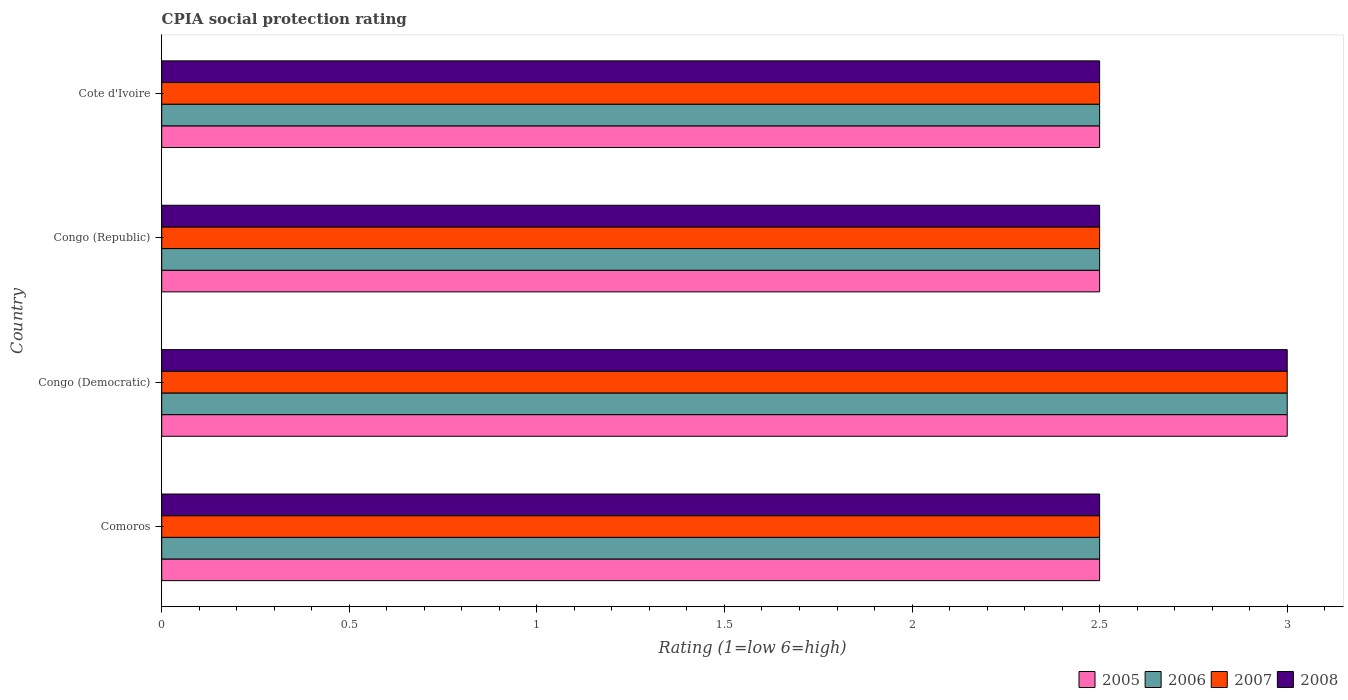Are the number of bars on each tick of the Y-axis equal?
Your answer should be compact. Yes. How many bars are there on the 3rd tick from the top?
Offer a terse response. 4. What is the label of the 2nd group of bars from the top?
Your response must be concise. Congo (Republic). In how many cases, is the number of bars for a given country not equal to the number of legend labels?
Make the answer very short. 0. What is the CPIA rating in 2006 in Cote d'Ivoire?
Your answer should be compact. 2.5. Across all countries, what is the maximum CPIA rating in 2005?
Give a very brief answer. 3. Across all countries, what is the minimum CPIA rating in 2005?
Make the answer very short. 2.5. In which country was the CPIA rating in 2008 maximum?
Ensure brevity in your answer.  Congo (Democratic). In which country was the CPIA rating in 2006 minimum?
Offer a terse response. Comoros. What is the total CPIA rating in 2005 in the graph?
Your response must be concise. 10.5. What is the difference between the CPIA rating in 2007 in Comoros and that in Cote d'Ivoire?
Provide a succinct answer. 0. What is the average CPIA rating in 2005 per country?
Offer a very short reply. 2.62. What is the difference between the CPIA rating in 2007 and CPIA rating in 2005 in Cote d'Ivoire?
Offer a very short reply. 0. In how many countries, is the CPIA rating in 2005 greater than 0.7 ?
Keep it short and to the point. 4. Is the difference between the CPIA rating in 2007 in Congo (Democratic) and Cote d'Ivoire greater than the difference between the CPIA rating in 2005 in Congo (Democratic) and Cote d'Ivoire?
Ensure brevity in your answer.  No. Is it the case that in every country, the sum of the CPIA rating in 2005 and CPIA rating in 2007 is greater than the sum of CPIA rating in 2006 and CPIA rating in 2008?
Your answer should be very brief. No. What does the 2nd bar from the top in Comoros represents?
Make the answer very short. 2007. What does the 3rd bar from the bottom in Congo (Democratic) represents?
Offer a very short reply. 2007. Is it the case that in every country, the sum of the CPIA rating in 2005 and CPIA rating in 2007 is greater than the CPIA rating in 2008?
Your answer should be very brief. Yes. How many bars are there?
Offer a terse response. 16. Are all the bars in the graph horizontal?
Offer a very short reply. Yes. What is the difference between two consecutive major ticks on the X-axis?
Your answer should be compact. 0.5. Are the values on the major ticks of X-axis written in scientific E-notation?
Ensure brevity in your answer.  No. Where does the legend appear in the graph?
Ensure brevity in your answer.  Bottom right. What is the title of the graph?
Your response must be concise. CPIA social protection rating. Does "1978" appear as one of the legend labels in the graph?
Offer a terse response. No. What is the label or title of the Y-axis?
Make the answer very short. Country. What is the Rating (1=low 6=high) in 2005 in Comoros?
Provide a succinct answer. 2.5. What is the Rating (1=low 6=high) of 2006 in Comoros?
Offer a very short reply. 2.5. What is the Rating (1=low 6=high) of 2007 in Comoros?
Offer a very short reply. 2.5. What is the Rating (1=low 6=high) in 2008 in Comoros?
Your answer should be compact. 2.5. What is the Rating (1=low 6=high) of 2005 in Congo (Democratic)?
Provide a short and direct response. 3. What is the Rating (1=low 6=high) in 2006 in Congo (Democratic)?
Your response must be concise. 3. What is the Rating (1=low 6=high) of 2007 in Congo (Democratic)?
Your answer should be very brief. 3. What is the Rating (1=low 6=high) of 2008 in Congo (Democratic)?
Give a very brief answer. 3. What is the Rating (1=low 6=high) in 2005 in Congo (Republic)?
Offer a terse response. 2.5. What is the Rating (1=low 6=high) in 2006 in Congo (Republic)?
Your answer should be compact. 2.5. What is the Rating (1=low 6=high) of 2008 in Congo (Republic)?
Your response must be concise. 2.5. What is the Rating (1=low 6=high) of 2005 in Cote d'Ivoire?
Provide a succinct answer. 2.5. What is the Rating (1=low 6=high) of 2006 in Cote d'Ivoire?
Make the answer very short. 2.5. What is the Rating (1=low 6=high) of 2007 in Cote d'Ivoire?
Your answer should be compact. 2.5. Across all countries, what is the maximum Rating (1=low 6=high) of 2005?
Your answer should be very brief. 3. Across all countries, what is the maximum Rating (1=low 6=high) of 2006?
Offer a terse response. 3. Across all countries, what is the maximum Rating (1=low 6=high) of 2008?
Your answer should be compact. 3. Across all countries, what is the minimum Rating (1=low 6=high) of 2006?
Make the answer very short. 2.5. Across all countries, what is the minimum Rating (1=low 6=high) of 2007?
Make the answer very short. 2.5. Across all countries, what is the minimum Rating (1=low 6=high) in 2008?
Your answer should be very brief. 2.5. What is the total Rating (1=low 6=high) of 2008 in the graph?
Offer a very short reply. 10.5. What is the difference between the Rating (1=low 6=high) of 2005 in Comoros and that in Congo (Democratic)?
Ensure brevity in your answer.  -0.5. What is the difference between the Rating (1=low 6=high) in 2007 in Comoros and that in Congo (Democratic)?
Your answer should be compact. -0.5. What is the difference between the Rating (1=low 6=high) of 2006 in Comoros and that in Congo (Republic)?
Give a very brief answer. 0. What is the difference between the Rating (1=low 6=high) in 2008 in Comoros and that in Congo (Republic)?
Offer a very short reply. 0. What is the difference between the Rating (1=low 6=high) of 2006 in Comoros and that in Cote d'Ivoire?
Make the answer very short. 0. What is the difference between the Rating (1=low 6=high) of 2008 in Comoros and that in Cote d'Ivoire?
Your response must be concise. 0. What is the difference between the Rating (1=low 6=high) of 2005 in Congo (Democratic) and that in Congo (Republic)?
Ensure brevity in your answer.  0.5. What is the difference between the Rating (1=low 6=high) of 2007 in Congo (Democratic) and that in Congo (Republic)?
Offer a terse response. 0.5. What is the difference between the Rating (1=low 6=high) in 2007 in Congo (Democratic) and that in Cote d'Ivoire?
Provide a succinct answer. 0.5. What is the difference between the Rating (1=low 6=high) in 2008 in Congo (Democratic) and that in Cote d'Ivoire?
Make the answer very short. 0.5. What is the difference between the Rating (1=low 6=high) of 2005 in Congo (Republic) and that in Cote d'Ivoire?
Offer a very short reply. 0. What is the difference between the Rating (1=low 6=high) in 2006 in Congo (Republic) and that in Cote d'Ivoire?
Your answer should be compact. 0. What is the difference between the Rating (1=low 6=high) of 2007 in Congo (Republic) and that in Cote d'Ivoire?
Offer a very short reply. 0. What is the difference between the Rating (1=low 6=high) of 2008 in Congo (Republic) and that in Cote d'Ivoire?
Your response must be concise. 0. What is the difference between the Rating (1=low 6=high) in 2005 in Comoros and the Rating (1=low 6=high) in 2006 in Congo (Democratic)?
Your answer should be compact. -0.5. What is the difference between the Rating (1=low 6=high) of 2005 in Comoros and the Rating (1=low 6=high) of 2007 in Congo (Republic)?
Keep it short and to the point. 0. What is the difference between the Rating (1=low 6=high) in 2005 in Comoros and the Rating (1=low 6=high) in 2008 in Congo (Republic)?
Make the answer very short. 0. What is the difference between the Rating (1=low 6=high) in 2006 in Comoros and the Rating (1=low 6=high) in 2007 in Congo (Republic)?
Give a very brief answer. 0. What is the difference between the Rating (1=low 6=high) in 2005 in Comoros and the Rating (1=low 6=high) in 2008 in Cote d'Ivoire?
Make the answer very short. 0. What is the difference between the Rating (1=low 6=high) in 2006 in Comoros and the Rating (1=low 6=high) in 2007 in Cote d'Ivoire?
Offer a terse response. 0. What is the difference between the Rating (1=low 6=high) of 2007 in Comoros and the Rating (1=low 6=high) of 2008 in Cote d'Ivoire?
Give a very brief answer. 0. What is the difference between the Rating (1=low 6=high) of 2006 in Congo (Democratic) and the Rating (1=low 6=high) of 2008 in Congo (Republic)?
Your answer should be compact. 0.5. What is the difference between the Rating (1=low 6=high) of 2005 in Congo (Democratic) and the Rating (1=low 6=high) of 2006 in Cote d'Ivoire?
Your answer should be very brief. 0.5. What is the difference between the Rating (1=low 6=high) of 2005 in Congo (Democratic) and the Rating (1=low 6=high) of 2008 in Cote d'Ivoire?
Offer a very short reply. 0.5. What is the difference between the Rating (1=low 6=high) in 2006 in Congo (Democratic) and the Rating (1=low 6=high) in 2008 in Cote d'Ivoire?
Your response must be concise. 0.5. What is the difference between the Rating (1=low 6=high) of 2007 in Congo (Democratic) and the Rating (1=low 6=high) of 2008 in Cote d'Ivoire?
Your answer should be very brief. 0.5. What is the difference between the Rating (1=low 6=high) in 2005 in Congo (Republic) and the Rating (1=low 6=high) in 2007 in Cote d'Ivoire?
Your answer should be compact. 0. What is the difference between the Rating (1=low 6=high) in 2005 in Congo (Republic) and the Rating (1=low 6=high) in 2008 in Cote d'Ivoire?
Provide a short and direct response. 0. What is the difference between the Rating (1=low 6=high) in 2007 in Congo (Republic) and the Rating (1=low 6=high) in 2008 in Cote d'Ivoire?
Your answer should be very brief. 0. What is the average Rating (1=low 6=high) of 2005 per country?
Keep it short and to the point. 2.62. What is the average Rating (1=low 6=high) of 2006 per country?
Make the answer very short. 2.62. What is the average Rating (1=low 6=high) in 2007 per country?
Offer a terse response. 2.62. What is the average Rating (1=low 6=high) of 2008 per country?
Keep it short and to the point. 2.62. What is the difference between the Rating (1=low 6=high) of 2005 and Rating (1=low 6=high) of 2006 in Comoros?
Keep it short and to the point. 0. What is the difference between the Rating (1=low 6=high) of 2006 and Rating (1=low 6=high) of 2007 in Comoros?
Give a very brief answer. 0. What is the difference between the Rating (1=low 6=high) in 2006 and Rating (1=low 6=high) in 2008 in Comoros?
Provide a succinct answer. 0. What is the difference between the Rating (1=low 6=high) in 2005 and Rating (1=low 6=high) in 2006 in Congo (Democratic)?
Offer a terse response. 0. What is the difference between the Rating (1=low 6=high) of 2005 and Rating (1=low 6=high) of 2008 in Congo (Democratic)?
Make the answer very short. 0. What is the difference between the Rating (1=low 6=high) of 2006 and Rating (1=low 6=high) of 2008 in Congo (Democratic)?
Keep it short and to the point. 0. What is the difference between the Rating (1=low 6=high) of 2007 and Rating (1=low 6=high) of 2008 in Congo (Democratic)?
Provide a succinct answer. 0. What is the difference between the Rating (1=low 6=high) in 2005 and Rating (1=low 6=high) in 2006 in Congo (Republic)?
Make the answer very short. 0. What is the difference between the Rating (1=low 6=high) in 2006 and Rating (1=low 6=high) in 2007 in Congo (Republic)?
Your answer should be very brief. 0. What is the difference between the Rating (1=low 6=high) of 2006 and Rating (1=low 6=high) of 2008 in Congo (Republic)?
Provide a short and direct response. 0. What is the difference between the Rating (1=low 6=high) of 2007 and Rating (1=low 6=high) of 2008 in Congo (Republic)?
Provide a succinct answer. 0. What is the difference between the Rating (1=low 6=high) in 2005 and Rating (1=low 6=high) in 2006 in Cote d'Ivoire?
Offer a very short reply. 0. What is the difference between the Rating (1=low 6=high) of 2006 and Rating (1=low 6=high) of 2007 in Cote d'Ivoire?
Give a very brief answer. 0. What is the difference between the Rating (1=low 6=high) in 2006 and Rating (1=low 6=high) in 2008 in Cote d'Ivoire?
Offer a very short reply. 0. What is the ratio of the Rating (1=low 6=high) in 2007 in Comoros to that in Congo (Democratic)?
Your response must be concise. 0.83. What is the ratio of the Rating (1=low 6=high) in 2005 in Comoros to that in Congo (Republic)?
Provide a succinct answer. 1. What is the ratio of the Rating (1=low 6=high) in 2007 in Comoros to that in Congo (Republic)?
Offer a terse response. 1. What is the ratio of the Rating (1=low 6=high) of 2006 in Comoros to that in Cote d'Ivoire?
Keep it short and to the point. 1. What is the ratio of the Rating (1=low 6=high) of 2007 in Comoros to that in Cote d'Ivoire?
Give a very brief answer. 1. What is the ratio of the Rating (1=low 6=high) in 2008 in Comoros to that in Cote d'Ivoire?
Make the answer very short. 1. What is the ratio of the Rating (1=low 6=high) in 2005 in Congo (Democratic) to that in Congo (Republic)?
Ensure brevity in your answer.  1.2. What is the ratio of the Rating (1=low 6=high) of 2007 in Congo (Democratic) to that in Congo (Republic)?
Your response must be concise. 1.2. What is the ratio of the Rating (1=low 6=high) in 2006 in Congo (Democratic) to that in Cote d'Ivoire?
Provide a succinct answer. 1.2. What is the ratio of the Rating (1=low 6=high) in 2007 in Congo (Democratic) to that in Cote d'Ivoire?
Ensure brevity in your answer.  1.2. What is the ratio of the Rating (1=low 6=high) of 2006 in Congo (Republic) to that in Cote d'Ivoire?
Your answer should be compact. 1. What is the ratio of the Rating (1=low 6=high) of 2007 in Congo (Republic) to that in Cote d'Ivoire?
Give a very brief answer. 1. What is the difference between the highest and the second highest Rating (1=low 6=high) of 2005?
Ensure brevity in your answer.  0.5. What is the difference between the highest and the second highest Rating (1=low 6=high) in 2007?
Offer a terse response. 0.5. What is the difference between the highest and the lowest Rating (1=low 6=high) of 2005?
Make the answer very short. 0.5. What is the difference between the highest and the lowest Rating (1=low 6=high) of 2006?
Give a very brief answer. 0.5. What is the difference between the highest and the lowest Rating (1=low 6=high) in 2007?
Keep it short and to the point. 0.5. What is the difference between the highest and the lowest Rating (1=low 6=high) in 2008?
Keep it short and to the point. 0.5. 